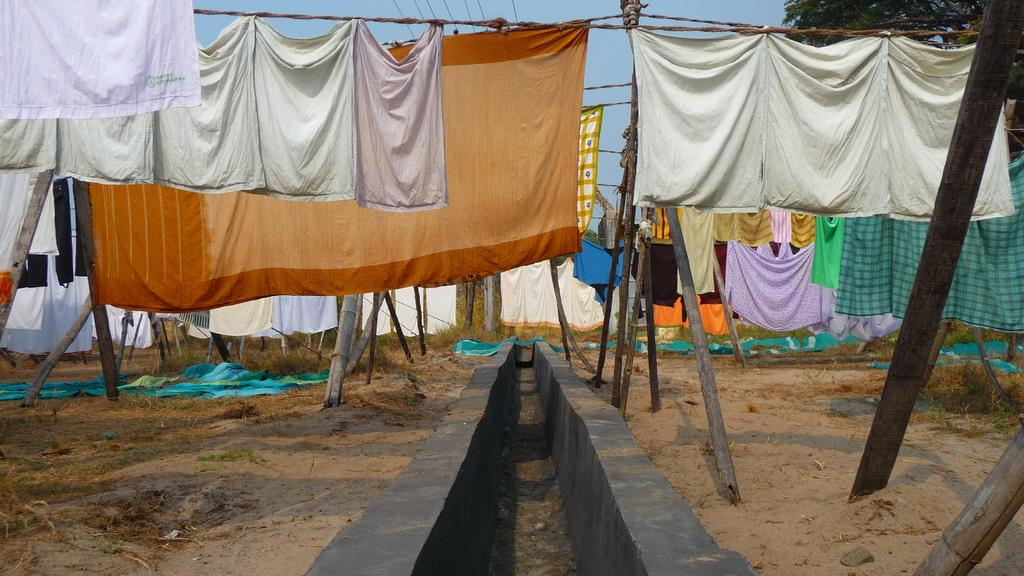How many rooms can be seen in the image? There are multiple rooms visible in the image. What can be seen hanging or placed in the rooms? Clothes are visible in the image. What type of material is present in the rooms? Wooden poles are present in the image. What type of outdoor environment is visible in the image? There is grass and a tree in the image. What is the condition of the sky in the image? The sky is clear in the image. How many tickets are visible in the image? There are no tickets present in the image. What type of love can be seen expressed between the wooden poles and the tree in the image? There is no love expressed between the wooden poles and the tree in the image; they are inanimate objects. 